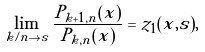Convert formula to latex. <formula><loc_0><loc_0><loc_500><loc_500>\lim _ { k / n \to s } \frac { P _ { k + 1 , n } ( x ) } { P _ { k , n } ( x ) } = z _ { 1 } ( x , s ) ,</formula> 